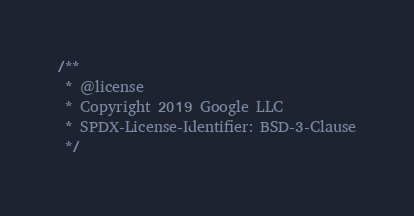Convert code to text. <code><loc_0><loc_0><loc_500><loc_500><_JavaScript_>/**
 * @license
 * Copyright 2019 Google LLC
 * SPDX-License-Identifier: BSD-3-Clause
 */</code> 